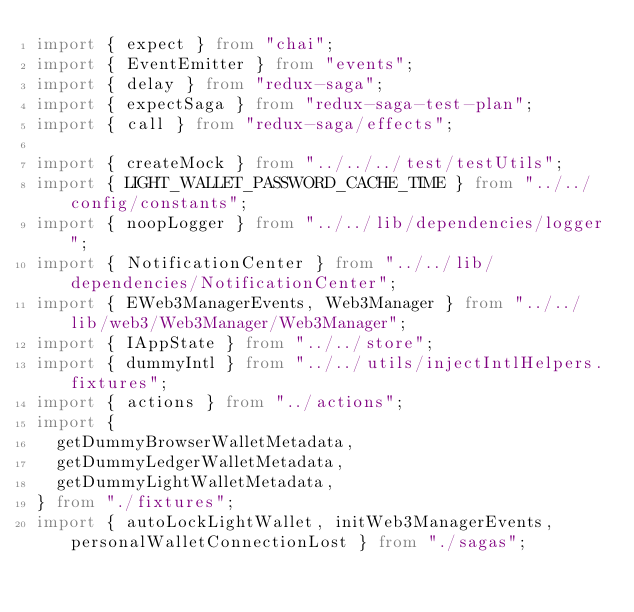Convert code to text. <code><loc_0><loc_0><loc_500><loc_500><_TypeScript_>import { expect } from "chai";
import { EventEmitter } from "events";
import { delay } from "redux-saga";
import { expectSaga } from "redux-saga-test-plan";
import { call } from "redux-saga/effects";

import { createMock } from "../../../test/testUtils";
import { LIGHT_WALLET_PASSWORD_CACHE_TIME } from "../../config/constants";
import { noopLogger } from "../../lib/dependencies/logger";
import { NotificationCenter } from "../../lib/dependencies/NotificationCenter";
import { EWeb3ManagerEvents, Web3Manager } from "../../lib/web3/Web3Manager/Web3Manager";
import { IAppState } from "../../store";
import { dummyIntl } from "../../utils/injectIntlHelpers.fixtures";
import { actions } from "../actions";
import {
  getDummyBrowserWalletMetadata,
  getDummyLedgerWalletMetadata,
  getDummyLightWalletMetadata,
} from "./fixtures";
import { autoLockLightWallet, initWeb3ManagerEvents, personalWalletConnectionLost } from "./sagas";
</code> 